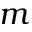<formula> <loc_0><loc_0><loc_500><loc_500>m</formula> 